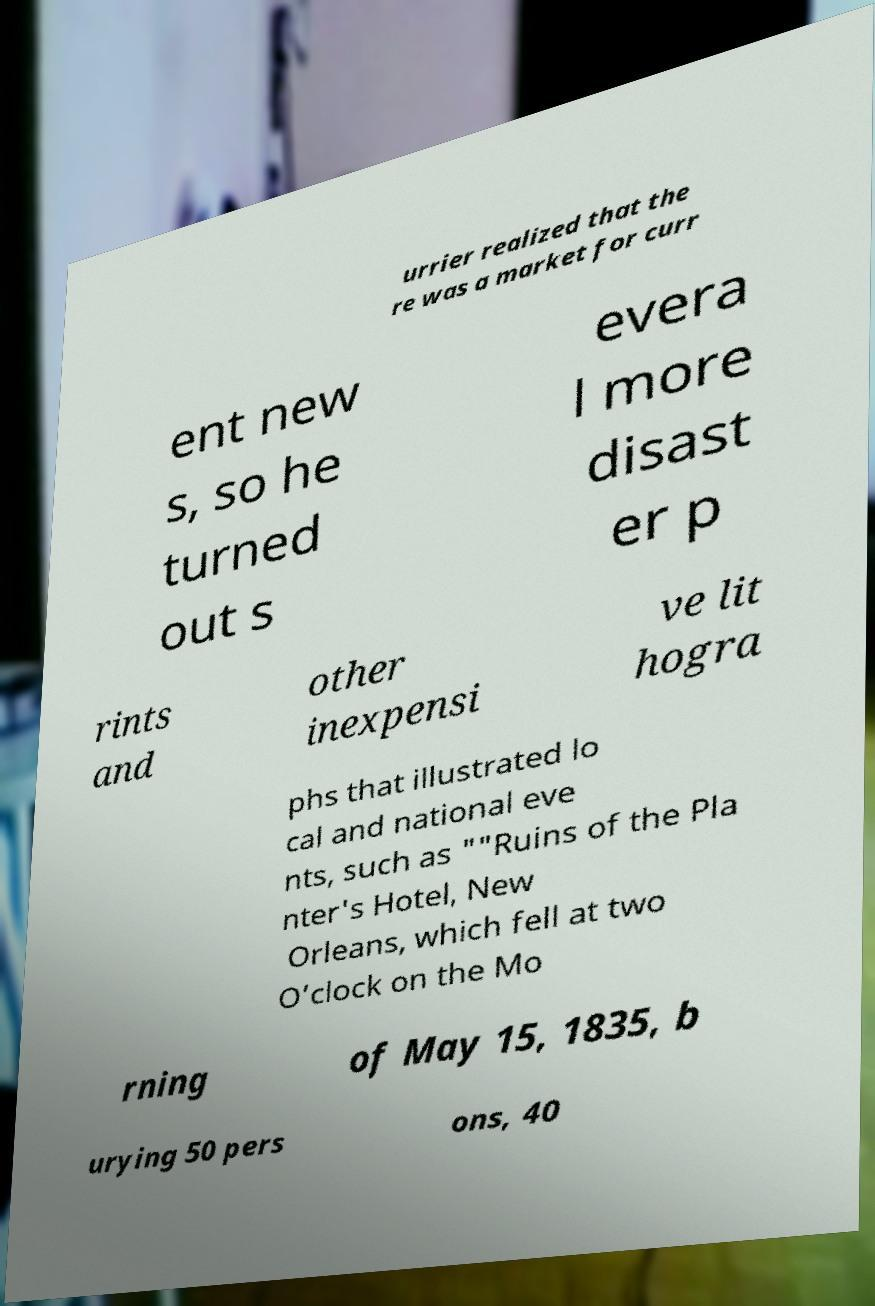For documentation purposes, I need the text within this image transcribed. Could you provide that? urrier realized that the re was a market for curr ent new s, so he turned out s evera l more disast er p rints and other inexpensi ve lit hogra phs that illustrated lo cal and national eve nts, such as ""Ruins of the Pla nter's Hotel, New Orleans, which fell at two O’clock on the Mo rning of May 15, 1835, b urying 50 pers ons, 40 